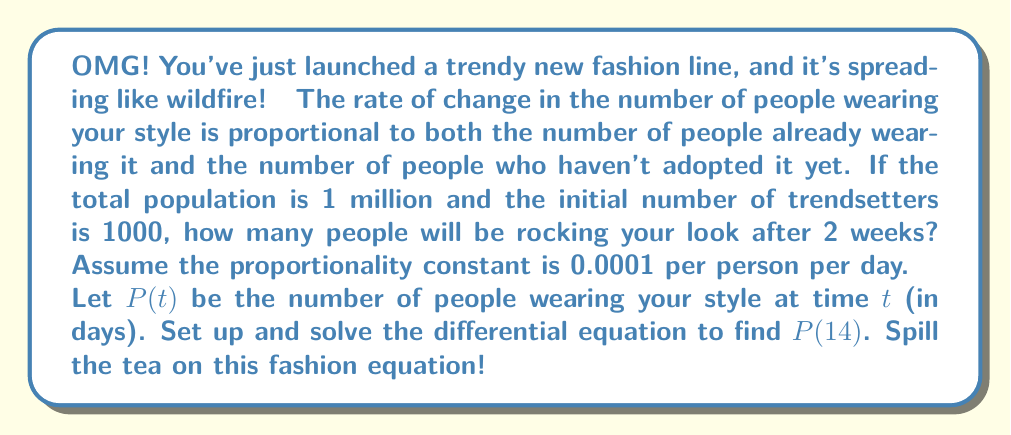What is the answer to this math problem? Alright, let's break this down step by step, bestie! 👯‍♀️

1) First, we need to set up our differential equation. The rate of change is proportional to both $P$ and $(1,000,000 - P)$:

   $$\frac{dP}{dt} = 0.0001P(1,000,000 - P)$$

2) This is a logistic growth equation! The general form is:

   $$\frac{dP}{dt} = kP(M - P)$$

   where $k = 0.0001$ and $M = 1,000,000$

3) The solution to this equation is:

   $$P(t) = \frac{M}{1 + (\frac{M}{P_0} - 1)e^{-kMt}}$$

   where $P_0$ is the initial population (1000 in this case)

4) Let's plug in our values:

   $$P(t) = \frac{1,000,000}{1 + (\frac{1,000,000}{1000} - 1)e^{-0.0001 \cdot 1,000,000 \cdot t}}$$

5) Simplify:

   $$P(t) = \frac{1,000,000}{1 + 999e^{-100t}}$$

6) Now, we want to find $P(14)$, so let's plug in $t = 14$:

   $$P(14) = \frac{1,000,000}{1 + 999e^{-100 \cdot 14}}$$

7) Calculate (you can use a calculator for this part):

   $$P(14) \approx 999,995$$

So, after 2 weeks, approximately 999,995 people will be wearing your trendy new style! That's hot! 🔥
Answer: 999,995 people 